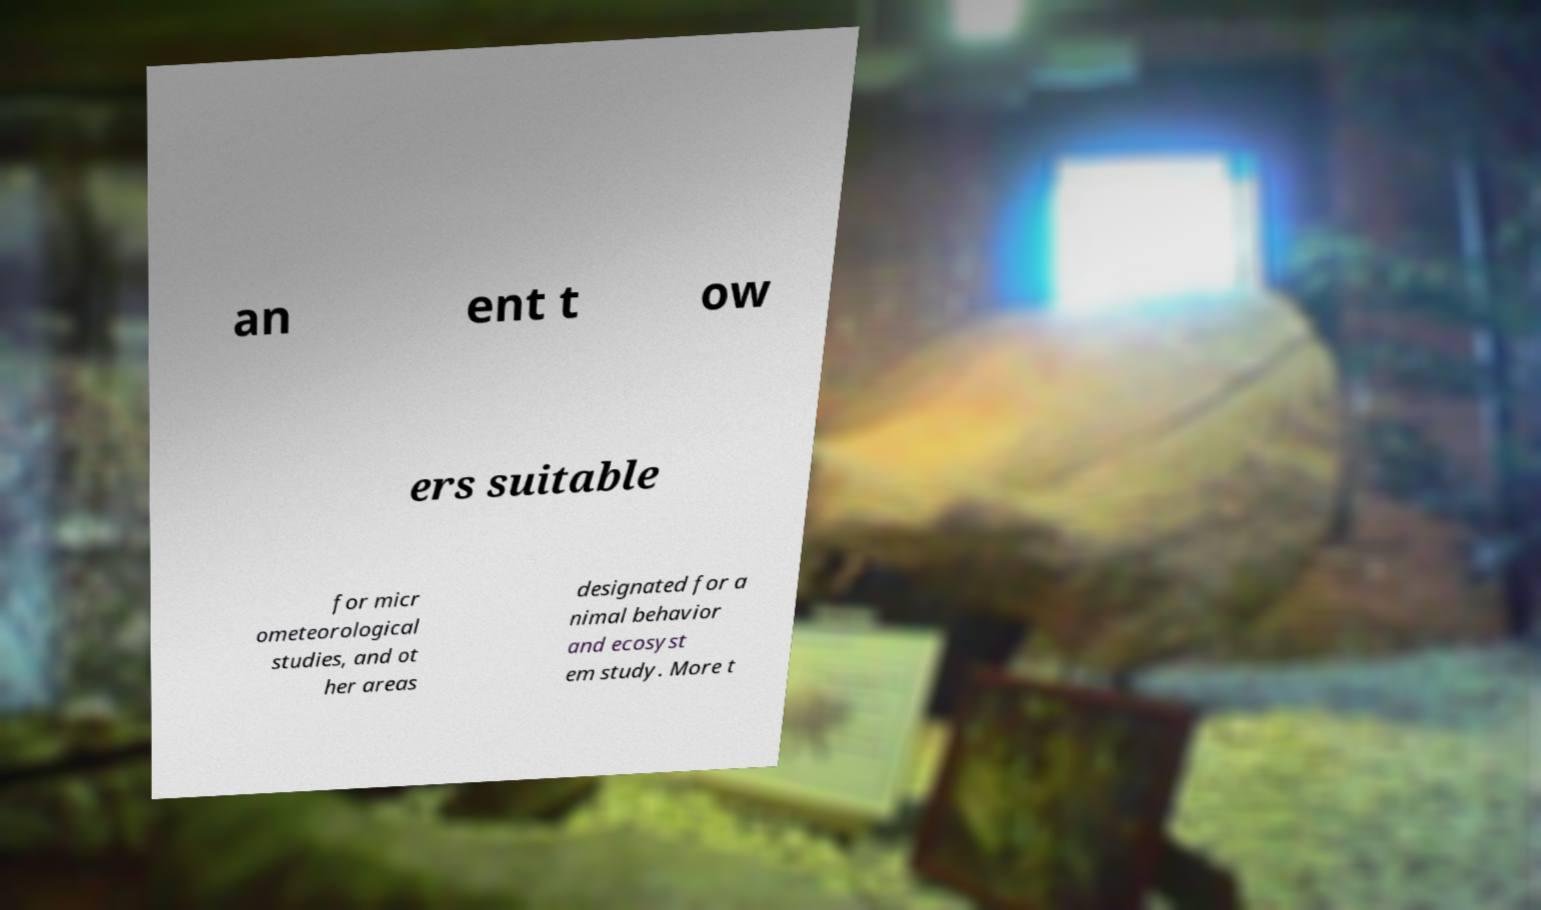What messages or text are displayed in this image? I need them in a readable, typed format. an ent t ow ers suitable for micr ometeorological studies, and ot her areas designated for a nimal behavior and ecosyst em study. More t 